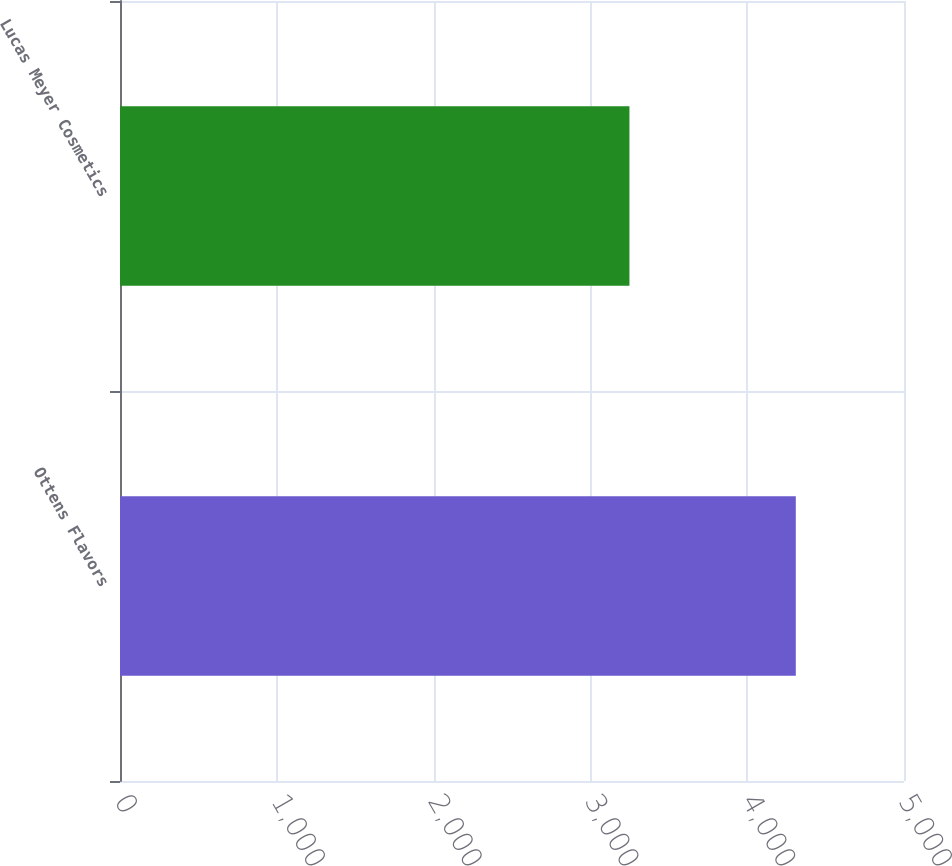<chart> <loc_0><loc_0><loc_500><loc_500><bar_chart><fcel>Ottens Flavors<fcel>Lucas Meyer Cosmetics<nl><fcel>4310<fcel>3249<nl></chart> 